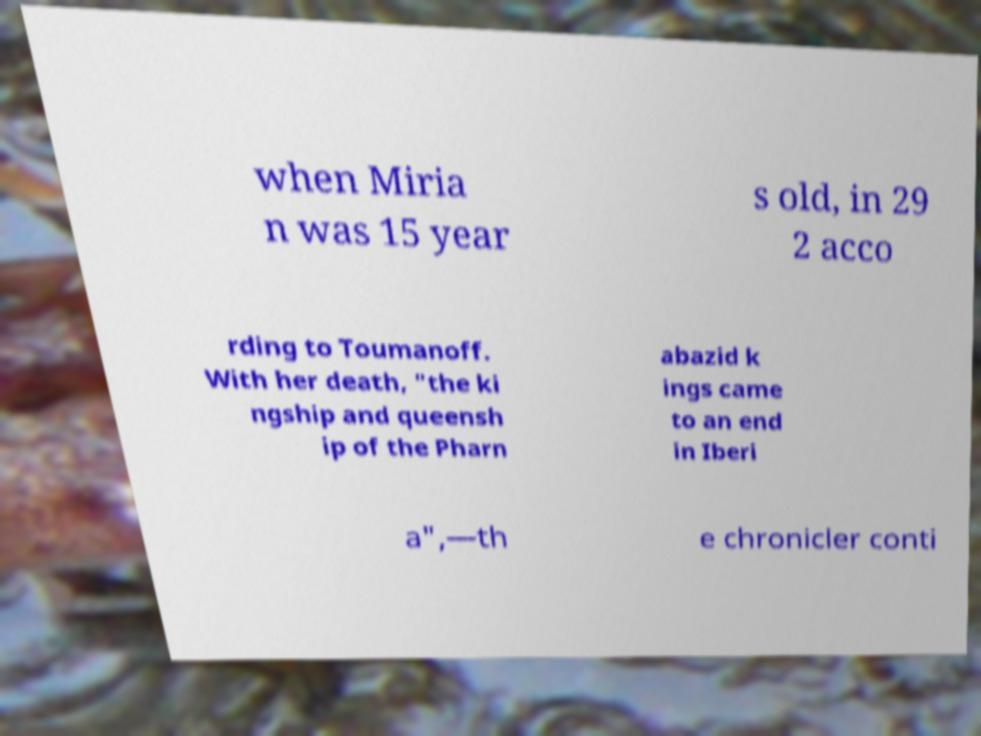Could you extract and type out the text from this image? when Miria n was 15 year s old, in 29 2 acco rding to Toumanoff. With her death, "the ki ngship and queensh ip of the Pharn abazid k ings came to an end in Iberi a",—th e chronicler conti 